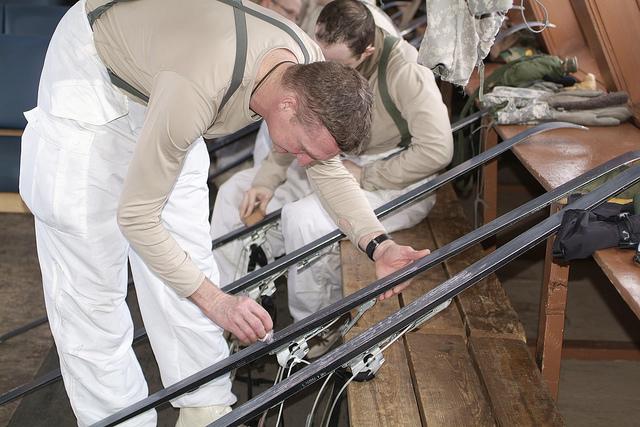What are they doing?
Short answer required. Waxing skis. Are these skiers?
Keep it brief. Yes. Are they wearing the same outfit?
Give a very brief answer. Yes. 